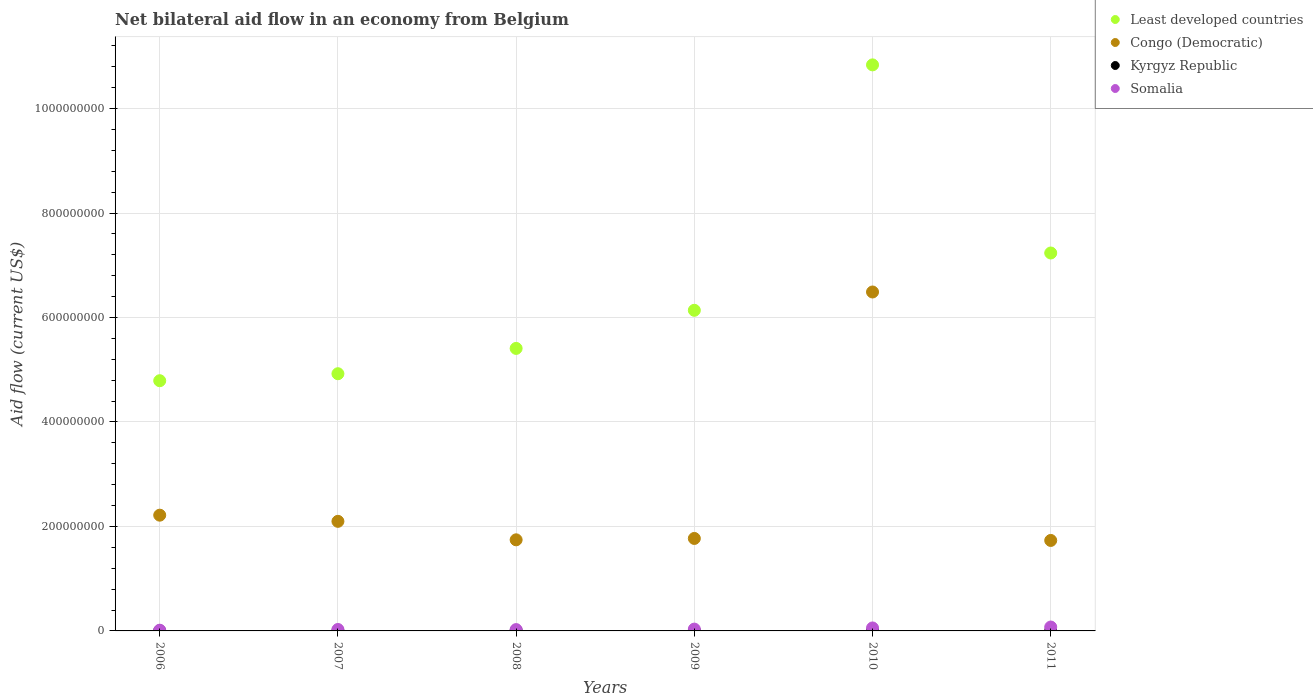How many different coloured dotlines are there?
Ensure brevity in your answer.  4. Is the number of dotlines equal to the number of legend labels?
Your answer should be compact. Yes. What is the net bilateral aid flow in Somalia in 2008?
Give a very brief answer. 2.56e+06. Across all years, what is the maximum net bilateral aid flow in Somalia?
Provide a succinct answer. 7.46e+06. Across all years, what is the minimum net bilateral aid flow in Kyrgyz Republic?
Ensure brevity in your answer.  1.40e+05. In which year was the net bilateral aid flow in Somalia maximum?
Offer a terse response. 2011. What is the total net bilateral aid flow in Somalia in the graph?
Keep it short and to the point. 2.34e+07. What is the difference between the net bilateral aid flow in Kyrgyz Republic in 2006 and the net bilateral aid flow in Least developed countries in 2011?
Your answer should be compact. -7.23e+08. What is the average net bilateral aid flow in Congo (Democratic) per year?
Give a very brief answer. 2.67e+08. In the year 2007, what is the difference between the net bilateral aid flow in Kyrgyz Republic and net bilateral aid flow in Somalia?
Provide a short and direct response. -2.62e+06. What is the ratio of the net bilateral aid flow in Least developed countries in 2007 to that in 2011?
Ensure brevity in your answer.  0.68. Is the net bilateral aid flow in Congo (Democratic) in 2009 less than that in 2011?
Keep it short and to the point. No. What is the difference between the highest and the second highest net bilateral aid flow in Congo (Democratic)?
Provide a succinct answer. 4.27e+08. What is the difference between the highest and the lowest net bilateral aid flow in Congo (Democratic)?
Make the answer very short. 4.76e+08. Is the sum of the net bilateral aid flow in Kyrgyz Republic in 2006 and 2009 greater than the maximum net bilateral aid flow in Somalia across all years?
Provide a succinct answer. No. Is it the case that in every year, the sum of the net bilateral aid flow in Kyrgyz Republic and net bilateral aid flow in Least developed countries  is greater than the net bilateral aid flow in Somalia?
Offer a very short reply. Yes. Is the net bilateral aid flow in Kyrgyz Republic strictly greater than the net bilateral aid flow in Congo (Democratic) over the years?
Your answer should be very brief. No. Is the net bilateral aid flow in Congo (Democratic) strictly less than the net bilateral aid flow in Kyrgyz Republic over the years?
Make the answer very short. No. How many dotlines are there?
Give a very brief answer. 4. How many years are there in the graph?
Keep it short and to the point. 6. Does the graph contain any zero values?
Provide a short and direct response. No. Does the graph contain grids?
Provide a succinct answer. Yes. Where does the legend appear in the graph?
Keep it short and to the point. Top right. What is the title of the graph?
Offer a terse response. Net bilateral aid flow in an economy from Belgium. What is the Aid flow (current US$) of Least developed countries in 2006?
Provide a short and direct response. 4.79e+08. What is the Aid flow (current US$) in Congo (Democratic) in 2006?
Give a very brief answer. 2.22e+08. What is the Aid flow (current US$) in Somalia in 2006?
Provide a succinct answer. 1.38e+06. What is the Aid flow (current US$) of Least developed countries in 2007?
Offer a terse response. 4.92e+08. What is the Aid flow (current US$) of Congo (Democratic) in 2007?
Provide a succinct answer. 2.10e+08. What is the Aid flow (current US$) of Kyrgyz Republic in 2007?
Give a very brief answer. 1.60e+05. What is the Aid flow (current US$) in Somalia in 2007?
Give a very brief answer. 2.78e+06. What is the Aid flow (current US$) of Least developed countries in 2008?
Your answer should be compact. 5.41e+08. What is the Aid flow (current US$) of Congo (Democratic) in 2008?
Make the answer very short. 1.74e+08. What is the Aid flow (current US$) in Kyrgyz Republic in 2008?
Offer a terse response. 6.30e+05. What is the Aid flow (current US$) in Somalia in 2008?
Provide a short and direct response. 2.56e+06. What is the Aid flow (current US$) in Least developed countries in 2009?
Offer a terse response. 6.14e+08. What is the Aid flow (current US$) in Congo (Democratic) in 2009?
Your answer should be very brief. 1.77e+08. What is the Aid flow (current US$) in Kyrgyz Republic in 2009?
Ensure brevity in your answer.  3.80e+05. What is the Aid flow (current US$) of Somalia in 2009?
Make the answer very short. 3.48e+06. What is the Aid flow (current US$) of Least developed countries in 2010?
Offer a very short reply. 1.08e+09. What is the Aid flow (current US$) in Congo (Democratic) in 2010?
Ensure brevity in your answer.  6.49e+08. What is the Aid flow (current US$) in Kyrgyz Republic in 2010?
Ensure brevity in your answer.  7.90e+05. What is the Aid flow (current US$) in Somalia in 2010?
Give a very brief answer. 5.69e+06. What is the Aid flow (current US$) of Least developed countries in 2011?
Offer a terse response. 7.23e+08. What is the Aid flow (current US$) in Congo (Democratic) in 2011?
Ensure brevity in your answer.  1.73e+08. What is the Aid flow (current US$) of Kyrgyz Republic in 2011?
Your answer should be compact. 1.40e+05. What is the Aid flow (current US$) in Somalia in 2011?
Keep it short and to the point. 7.46e+06. Across all years, what is the maximum Aid flow (current US$) in Least developed countries?
Provide a succinct answer. 1.08e+09. Across all years, what is the maximum Aid flow (current US$) in Congo (Democratic)?
Your response must be concise. 6.49e+08. Across all years, what is the maximum Aid flow (current US$) in Kyrgyz Republic?
Provide a short and direct response. 7.90e+05. Across all years, what is the maximum Aid flow (current US$) in Somalia?
Offer a very short reply. 7.46e+06. Across all years, what is the minimum Aid flow (current US$) of Least developed countries?
Your response must be concise. 4.79e+08. Across all years, what is the minimum Aid flow (current US$) in Congo (Democratic)?
Your response must be concise. 1.73e+08. Across all years, what is the minimum Aid flow (current US$) in Kyrgyz Republic?
Provide a short and direct response. 1.40e+05. Across all years, what is the minimum Aid flow (current US$) of Somalia?
Your answer should be very brief. 1.38e+06. What is the total Aid flow (current US$) of Least developed countries in the graph?
Provide a short and direct response. 3.93e+09. What is the total Aid flow (current US$) of Congo (Democratic) in the graph?
Provide a succinct answer. 1.60e+09. What is the total Aid flow (current US$) in Kyrgyz Republic in the graph?
Give a very brief answer. 2.29e+06. What is the total Aid flow (current US$) of Somalia in the graph?
Your answer should be very brief. 2.34e+07. What is the difference between the Aid flow (current US$) in Least developed countries in 2006 and that in 2007?
Ensure brevity in your answer.  -1.34e+07. What is the difference between the Aid flow (current US$) in Congo (Democratic) in 2006 and that in 2007?
Offer a very short reply. 1.18e+07. What is the difference between the Aid flow (current US$) of Somalia in 2006 and that in 2007?
Offer a terse response. -1.40e+06. What is the difference between the Aid flow (current US$) of Least developed countries in 2006 and that in 2008?
Offer a very short reply. -6.18e+07. What is the difference between the Aid flow (current US$) of Congo (Democratic) in 2006 and that in 2008?
Your answer should be compact. 4.72e+07. What is the difference between the Aid flow (current US$) of Kyrgyz Republic in 2006 and that in 2008?
Offer a terse response. -4.40e+05. What is the difference between the Aid flow (current US$) in Somalia in 2006 and that in 2008?
Keep it short and to the point. -1.18e+06. What is the difference between the Aid flow (current US$) of Least developed countries in 2006 and that in 2009?
Provide a short and direct response. -1.35e+08. What is the difference between the Aid flow (current US$) of Congo (Democratic) in 2006 and that in 2009?
Provide a succinct answer. 4.46e+07. What is the difference between the Aid flow (current US$) of Kyrgyz Republic in 2006 and that in 2009?
Your answer should be very brief. -1.90e+05. What is the difference between the Aid flow (current US$) of Somalia in 2006 and that in 2009?
Make the answer very short. -2.10e+06. What is the difference between the Aid flow (current US$) of Least developed countries in 2006 and that in 2010?
Keep it short and to the point. -6.05e+08. What is the difference between the Aid flow (current US$) of Congo (Democratic) in 2006 and that in 2010?
Provide a short and direct response. -4.27e+08. What is the difference between the Aid flow (current US$) of Kyrgyz Republic in 2006 and that in 2010?
Provide a short and direct response. -6.00e+05. What is the difference between the Aid flow (current US$) of Somalia in 2006 and that in 2010?
Keep it short and to the point. -4.31e+06. What is the difference between the Aid flow (current US$) in Least developed countries in 2006 and that in 2011?
Ensure brevity in your answer.  -2.44e+08. What is the difference between the Aid flow (current US$) in Congo (Democratic) in 2006 and that in 2011?
Your answer should be very brief. 4.84e+07. What is the difference between the Aid flow (current US$) in Kyrgyz Republic in 2006 and that in 2011?
Provide a succinct answer. 5.00e+04. What is the difference between the Aid flow (current US$) in Somalia in 2006 and that in 2011?
Offer a terse response. -6.08e+06. What is the difference between the Aid flow (current US$) of Least developed countries in 2007 and that in 2008?
Ensure brevity in your answer.  -4.85e+07. What is the difference between the Aid flow (current US$) in Congo (Democratic) in 2007 and that in 2008?
Ensure brevity in your answer.  3.54e+07. What is the difference between the Aid flow (current US$) of Kyrgyz Republic in 2007 and that in 2008?
Make the answer very short. -4.70e+05. What is the difference between the Aid flow (current US$) in Somalia in 2007 and that in 2008?
Make the answer very short. 2.20e+05. What is the difference between the Aid flow (current US$) of Least developed countries in 2007 and that in 2009?
Provide a succinct answer. -1.21e+08. What is the difference between the Aid flow (current US$) in Congo (Democratic) in 2007 and that in 2009?
Offer a terse response. 3.28e+07. What is the difference between the Aid flow (current US$) of Somalia in 2007 and that in 2009?
Keep it short and to the point. -7.00e+05. What is the difference between the Aid flow (current US$) of Least developed countries in 2007 and that in 2010?
Your answer should be compact. -5.91e+08. What is the difference between the Aid flow (current US$) of Congo (Democratic) in 2007 and that in 2010?
Ensure brevity in your answer.  -4.39e+08. What is the difference between the Aid flow (current US$) of Kyrgyz Republic in 2007 and that in 2010?
Make the answer very short. -6.30e+05. What is the difference between the Aid flow (current US$) of Somalia in 2007 and that in 2010?
Give a very brief answer. -2.91e+06. What is the difference between the Aid flow (current US$) in Least developed countries in 2007 and that in 2011?
Ensure brevity in your answer.  -2.31e+08. What is the difference between the Aid flow (current US$) of Congo (Democratic) in 2007 and that in 2011?
Your answer should be compact. 3.66e+07. What is the difference between the Aid flow (current US$) in Kyrgyz Republic in 2007 and that in 2011?
Your response must be concise. 2.00e+04. What is the difference between the Aid flow (current US$) of Somalia in 2007 and that in 2011?
Give a very brief answer. -4.68e+06. What is the difference between the Aid flow (current US$) in Least developed countries in 2008 and that in 2009?
Your response must be concise. -7.29e+07. What is the difference between the Aid flow (current US$) in Congo (Democratic) in 2008 and that in 2009?
Make the answer very short. -2.64e+06. What is the difference between the Aid flow (current US$) in Kyrgyz Republic in 2008 and that in 2009?
Offer a terse response. 2.50e+05. What is the difference between the Aid flow (current US$) of Somalia in 2008 and that in 2009?
Your response must be concise. -9.20e+05. What is the difference between the Aid flow (current US$) in Least developed countries in 2008 and that in 2010?
Keep it short and to the point. -5.43e+08. What is the difference between the Aid flow (current US$) in Congo (Democratic) in 2008 and that in 2010?
Provide a short and direct response. -4.74e+08. What is the difference between the Aid flow (current US$) in Somalia in 2008 and that in 2010?
Keep it short and to the point. -3.13e+06. What is the difference between the Aid flow (current US$) in Least developed countries in 2008 and that in 2011?
Provide a succinct answer. -1.83e+08. What is the difference between the Aid flow (current US$) of Congo (Democratic) in 2008 and that in 2011?
Offer a terse response. 1.19e+06. What is the difference between the Aid flow (current US$) in Somalia in 2008 and that in 2011?
Provide a short and direct response. -4.90e+06. What is the difference between the Aid flow (current US$) of Least developed countries in 2009 and that in 2010?
Keep it short and to the point. -4.70e+08. What is the difference between the Aid flow (current US$) of Congo (Democratic) in 2009 and that in 2010?
Keep it short and to the point. -4.72e+08. What is the difference between the Aid flow (current US$) in Kyrgyz Republic in 2009 and that in 2010?
Make the answer very short. -4.10e+05. What is the difference between the Aid flow (current US$) in Somalia in 2009 and that in 2010?
Offer a very short reply. -2.21e+06. What is the difference between the Aid flow (current US$) in Least developed countries in 2009 and that in 2011?
Give a very brief answer. -1.10e+08. What is the difference between the Aid flow (current US$) of Congo (Democratic) in 2009 and that in 2011?
Make the answer very short. 3.83e+06. What is the difference between the Aid flow (current US$) in Somalia in 2009 and that in 2011?
Keep it short and to the point. -3.98e+06. What is the difference between the Aid flow (current US$) of Least developed countries in 2010 and that in 2011?
Offer a terse response. 3.60e+08. What is the difference between the Aid flow (current US$) of Congo (Democratic) in 2010 and that in 2011?
Provide a short and direct response. 4.76e+08. What is the difference between the Aid flow (current US$) of Kyrgyz Republic in 2010 and that in 2011?
Offer a terse response. 6.50e+05. What is the difference between the Aid flow (current US$) of Somalia in 2010 and that in 2011?
Your response must be concise. -1.77e+06. What is the difference between the Aid flow (current US$) of Least developed countries in 2006 and the Aid flow (current US$) of Congo (Democratic) in 2007?
Give a very brief answer. 2.69e+08. What is the difference between the Aid flow (current US$) of Least developed countries in 2006 and the Aid flow (current US$) of Kyrgyz Republic in 2007?
Offer a terse response. 4.79e+08. What is the difference between the Aid flow (current US$) of Least developed countries in 2006 and the Aid flow (current US$) of Somalia in 2007?
Your answer should be compact. 4.76e+08. What is the difference between the Aid flow (current US$) in Congo (Democratic) in 2006 and the Aid flow (current US$) in Kyrgyz Republic in 2007?
Keep it short and to the point. 2.21e+08. What is the difference between the Aid flow (current US$) in Congo (Democratic) in 2006 and the Aid flow (current US$) in Somalia in 2007?
Offer a very short reply. 2.19e+08. What is the difference between the Aid flow (current US$) of Kyrgyz Republic in 2006 and the Aid flow (current US$) of Somalia in 2007?
Keep it short and to the point. -2.59e+06. What is the difference between the Aid flow (current US$) in Least developed countries in 2006 and the Aid flow (current US$) in Congo (Democratic) in 2008?
Provide a succinct answer. 3.05e+08. What is the difference between the Aid flow (current US$) in Least developed countries in 2006 and the Aid flow (current US$) in Kyrgyz Republic in 2008?
Your response must be concise. 4.78e+08. What is the difference between the Aid flow (current US$) in Least developed countries in 2006 and the Aid flow (current US$) in Somalia in 2008?
Give a very brief answer. 4.76e+08. What is the difference between the Aid flow (current US$) of Congo (Democratic) in 2006 and the Aid flow (current US$) of Kyrgyz Republic in 2008?
Ensure brevity in your answer.  2.21e+08. What is the difference between the Aid flow (current US$) of Congo (Democratic) in 2006 and the Aid flow (current US$) of Somalia in 2008?
Your answer should be very brief. 2.19e+08. What is the difference between the Aid flow (current US$) of Kyrgyz Republic in 2006 and the Aid flow (current US$) of Somalia in 2008?
Your answer should be very brief. -2.37e+06. What is the difference between the Aid flow (current US$) in Least developed countries in 2006 and the Aid flow (current US$) in Congo (Democratic) in 2009?
Ensure brevity in your answer.  3.02e+08. What is the difference between the Aid flow (current US$) in Least developed countries in 2006 and the Aid flow (current US$) in Kyrgyz Republic in 2009?
Offer a very short reply. 4.79e+08. What is the difference between the Aid flow (current US$) of Least developed countries in 2006 and the Aid flow (current US$) of Somalia in 2009?
Give a very brief answer. 4.75e+08. What is the difference between the Aid flow (current US$) in Congo (Democratic) in 2006 and the Aid flow (current US$) in Kyrgyz Republic in 2009?
Provide a succinct answer. 2.21e+08. What is the difference between the Aid flow (current US$) in Congo (Democratic) in 2006 and the Aid flow (current US$) in Somalia in 2009?
Your answer should be very brief. 2.18e+08. What is the difference between the Aid flow (current US$) in Kyrgyz Republic in 2006 and the Aid flow (current US$) in Somalia in 2009?
Give a very brief answer. -3.29e+06. What is the difference between the Aid flow (current US$) in Least developed countries in 2006 and the Aid flow (current US$) in Congo (Democratic) in 2010?
Your response must be concise. -1.70e+08. What is the difference between the Aid flow (current US$) of Least developed countries in 2006 and the Aid flow (current US$) of Kyrgyz Republic in 2010?
Offer a very short reply. 4.78e+08. What is the difference between the Aid flow (current US$) of Least developed countries in 2006 and the Aid flow (current US$) of Somalia in 2010?
Your response must be concise. 4.73e+08. What is the difference between the Aid flow (current US$) of Congo (Democratic) in 2006 and the Aid flow (current US$) of Kyrgyz Republic in 2010?
Make the answer very short. 2.21e+08. What is the difference between the Aid flow (current US$) in Congo (Democratic) in 2006 and the Aid flow (current US$) in Somalia in 2010?
Your answer should be compact. 2.16e+08. What is the difference between the Aid flow (current US$) of Kyrgyz Republic in 2006 and the Aid flow (current US$) of Somalia in 2010?
Your answer should be compact. -5.50e+06. What is the difference between the Aid flow (current US$) of Least developed countries in 2006 and the Aid flow (current US$) of Congo (Democratic) in 2011?
Your answer should be very brief. 3.06e+08. What is the difference between the Aid flow (current US$) in Least developed countries in 2006 and the Aid flow (current US$) in Kyrgyz Republic in 2011?
Ensure brevity in your answer.  4.79e+08. What is the difference between the Aid flow (current US$) of Least developed countries in 2006 and the Aid flow (current US$) of Somalia in 2011?
Your answer should be very brief. 4.72e+08. What is the difference between the Aid flow (current US$) of Congo (Democratic) in 2006 and the Aid flow (current US$) of Kyrgyz Republic in 2011?
Ensure brevity in your answer.  2.21e+08. What is the difference between the Aid flow (current US$) in Congo (Democratic) in 2006 and the Aid flow (current US$) in Somalia in 2011?
Offer a terse response. 2.14e+08. What is the difference between the Aid flow (current US$) in Kyrgyz Republic in 2006 and the Aid flow (current US$) in Somalia in 2011?
Your answer should be compact. -7.27e+06. What is the difference between the Aid flow (current US$) in Least developed countries in 2007 and the Aid flow (current US$) in Congo (Democratic) in 2008?
Your response must be concise. 3.18e+08. What is the difference between the Aid flow (current US$) of Least developed countries in 2007 and the Aid flow (current US$) of Kyrgyz Republic in 2008?
Provide a short and direct response. 4.92e+08. What is the difference between the Aid flow (current US$) of Least developed countries in 2007 and the Aid flow (current US$) of Somalia in 2008?
Make the answer very short. 4.90e+08. What is the difference between the Aid flow (current US$) in Congo (Democratic) in 2007 and the Aid flow (current US$) in Kyrgyz Republic in 2008?
Keep it short and to the point. 2.09e+08. What is the difference between the Aid flow (current US$) in Congo (Democratic) in 2007 and the Aid flow (current US$) in Somalia in 2008?
Keep it short and to the point. 2.07e+08. What is the difference between the Aid flow (current US$) in Kyrgyz Republic in 2007 and the Aid flow (current US$) in Somalia in 2008?
Offer a very short reply. -2.40e+06. What is the difference between the Aid flow (current US$) of Least developed countries in 2007 and the Aid flow (current US$) of Congo (Democratic) in 2009?
Your answer should be compact. 3.15e+08. What is the difference between the Aid flow (current US$) of Least developed countries in 2007 and the Aid flow (current US$) of Kyrgyz Republic in 2009?
Give a very brief answer. 4.92e+08. What is the difference between the Aid flow (current US$) in Least developed countries in 2007 and the Aid flow (current US$) in Somalia in 2009?
Make the answer very short. 4.89e+08. What is the difference between the Aid flow (current US$) of Congo (Democratic) in 2007 and the Aid flow (current US$) of Kyrgyz Republic in 2009?
Provide a short and direct response. 2.09e+08. What is the difference between the Aid flow (current US$) in Congo (Democratic) in 2007 and the Aid flow (current US$) in Somalia in 2009?
Your answer should be very brief. 2.06e+08. What is the difference between the Aid flow (current US$) in Kyrgyz Republic in 2007 and the Aid flow (current US$) in Somalia in 2009?
Your answer should be very brief. -3.32e+06. What is the difference between the Aid flow (current US$) in Least developed countries in 2007 and the Aid flow (current US$) in Congo (Democratic) in 2010?
Provide a short and direct response. -1.56e+08. What is the difference between the Aid flow (current US$) of Least developed countries in 2007 and the Aid flow (current US$) of Kyrgyz Republic in 2010?
Your answer should be very brief. 4.92e+08. What is the difference between the Aid flow (current US$) of Least developed countries in 2007 and the Aid flow (current US$) of Somalia in 2010?
Ensure brevity in your answer.  4.87e+08. What is the difference between the Aid flow (current US$) of Congo (Democratic) in 2007 and the Aid flow (current US$) of Kyrgyz Republic in 2010?
Provide a succinct answer. 2.09e+08. What is the difference between the Aid flow (current US$) of Congo (Democratic) in 2007 and the Aid flow (current US$) of Somalia in 2010?
Your response must be concise. 2.04e+08. What is the difference between the Aid flow (current US$) of Kyrgyz Republic in 2007 and the Aid flow (current US$) of Somalia in 2010?
Offer a terse response. -5.53e+06. What is the difference between the Aid flow (current US$) of Least developed countries in 2007 and the Aid flow (current US$) of Congo (Democratic) in 2011?
Your answer should be very brief. 3.19e+08. What is the difference between the Aid flow (current US$) in Least developed countries in 2007 and the Aid flow (current US$) in Kyrgyz Republic in 2011?
Provide a succinct answer. 4.92e+08. What is the difference between the Aid flow (current US$) in Least developed countries in 2007 and the Aid flow (current US$) in Somalia in 2011?
Offer a very short reply. 4.85e+08. What is the difference between the Aid flow (current US$) in Congo (Democratic) in 2007 and the Aid flow (current US$) in Kyrgyz Republic in 2011?
Your response must be concise. 2.10e+08. What is the difference between the Aid flow (current US$) of Congo (Democratic) in 2007 and the Aid flow (current US$) of Somalia in 2011?
Provide a short and direct response. 2.02e+08. What is the difference between the Aid flow (current US$) in Kyrgyz Republic in 2007 and the Aid flow (current US$) in Somalia in 2011?
Offer a very short reply. -7.30e+06. What is the difference between the Aid flow (current US$) of Least developed countries in 2008 and the Aid flow (current US$) of Congo (Democratic) in 2009?
Keep it short and to the point. 3.64e+08. What is the difference between the Aid flow (current US$) of Least developed countries in 2008 and the Aid flow (current US$) of Kyrgyz Republic in 2009?
Offer a very short reply. 5.40e+08. What is the difference between the Aid flow (current US$) of Least developed countries in 2008 and the Aid flow (current US$) of Somalia in 2009?
Your answer should be compact. 5.37e+08. What is the difference between the Aid flow (current US$) of Congo (Democratic) in 2008 and the Aid flow (current US$) of Kyrgyz Republic in 2009?
Your answer should be very brief. 1.74e+08. What is the difference between the Aid flow (current US$) in Congo (Democratic) in 2008 and the Aid flow (current US$) in Somalia in 2009?
Make the answer very short. 1.71e+08. What is the difference between the Aid flow (current US$) of Kyrgyz Republic in 2008 and the Aid flow (current US$) of Somalia in 2009?
Provide a short and direct response. -2.85e+06. What is the difference between the Aid flow (current US$) in Least developed countries in 2008 and the Aid flow (current US$) in Congo (Democratic) in 2010?
Your answer should be very brief. -1.08e+08. What is the difference between the Aid flow (current US$) in Least developed countries in 2008 and the Aid flow (current US$) in Kyrgyz Republic in 2010?
Keep it short and to the point. 5.40e+08. What is the difference between the Aid flow (current US$) in Least developed countries in 2008 and the Aid flow (current US$) in Somalia in 2010?
Offer a terse response. 5.35e+08. What is the difference between the Aid flow (current US$) of Congo (Democratic) in 2008 and the Aid flow (current US$) of Kyrgyz Republic in 2010?
Offer a very short reply. 1.74e+08. What is the difference between the Aid flow (current US$) of Congo (Democratic) in 2008 and the Aid flow (current US$) of Somalia in 2010?
Make the answer very short. 1.69e+08. What is the difference between the Aid flow (current US$) of Kyrgyz Republic in 2008 and the Aid flow (current US$) of Somalia in 2010?
Offer a very short reply. -5.06e+06. What is the difference between the Aid flow (current US$) of Least developed countries in 2008 and the Aid flow (current US$) of Congo (Democratic) in 2011?
Your response must be concise. 3.68e+08. What is the difference between the Aid flow (current US$) in Least developed countries in 2008 and the Aid flow (current US$) in Kyrgyz Republic in 2011?
Your answer should be compact. 5.41e+08. What is the difference between the Aid flow (current US$) in Least developed countries in 2008 and the Aid flow (current US$) in Somalia in 2011?
Your answer should be compact. 5.33e+08. What is the difference between the Aid flow (current US$) in Congo (Democratic) in 2008 and the Aid flow (current US$) in Kyrgyz Republic in 2011?
Your response must be concise. 1.74e+08. What is the difference between the Aid flow (current US$) in Congo (Democratic) in 2008 and the Aid flow (current US$) in Somalia in 2011?
Provide a short and direct response. 1.67e+08. What is the difference between the Aid flow (current US$) of Kyrgyz Republic in 2008 and the Aid flow (current US$) of Somalia in 2011?
Make the answer very short. -6.83e+06. What is the difference between the Aid flow (current US$) in Least developed countries in 2009 and the Aid flow (current US$) in Congo (Democratic) in 2010?
Give a very brief answer. -3.51e+07. What is the difference between the Aid flow (current US$) of Least developed countries in 2009 and the Aid flow (current US$) of Kyrgyz Republic in 2010?
Provide a succinct answer. 6.13e+08. What is the difference between the Aid flow (current US$) in Least developed countries in 2009 and the Aid flow (current US$) in Somalia in 2010?
Give a very brief answer. 6.08e+08. What is the difference between the Aid flow (current US$) in Congo (Democratic) in 2009 and the Aid flow (current US$) in Kyrgyz Republic in 2010?
Ensure brevity in your answer.  1.76e+08. What is the difference between the Aid flow (current US$) of Congo (Democratic) in 2009 and the Aid flow (current US$) of Somalia in 2010?
Provide a succinct answer. 1.71e+08. What is the difference between the Aid flow (current US$) in Kyrgyz Republic in 2009 and the Aid flow (current US$) in Somalia in 2010?
Give a very brief answer. -5.31e+06. What is the difference between the Aid flow (current US$) of Least developed countries in 2009 and the Aid flow (current US$) of Congo (Democratic) in 2011?
Your answer should be very brief. 4.41e+08. What is the difference between the Aid flow (current US$) of Least developed countries in 2009 and the Aid flow (current US$) of Kyrgyz Republic in 2011?
Your answer should be very brief. 6.14e+08. What is the difference between the Aid flow (current US$) of Least developed countries in 2009 and the Aid flow (current US$) of Somalia in 2011?
Ensure brevity in your answer.  6.06e+08. What is the difference between the Aid flow (current US$) in Congo (Democratic) in 2009 and the Aid flow (current US$) in Kyrgyz Republic in 2011?
Keep it short and to the point. 1.77e+08. What is the difference between the Aid flow (current US$) of Congo (Democratic) in 2009 and the Aid flow (current US$) of Somalia in 2011?
Offer a terse response. 1.70e+08. What is the difference between the Aid flow (current US$) in Kyrgyz Republic in 2009 and the Aid flow (current US$) in Somalia in 2011?
Your response must be concise. -7.08e+06. What is the difference between the Aid flow (current US$) of Least developed countries in 2010 and the Aid flow (current US$) of Congo (Democratic) in 2011?
Offer a terse response. 9.10e+08. What is the difference between the Aid flow (current US$) of Least developed countries in 2010 and the Aid flow (current US$) of Kyrgyz Republic in 2011?
Provide a succinct answer. 1.08e+09. What is the difference between the Aid flow (current US$) in Least developed countries in 2010 and the Aid flow (current US$) in Somalia in 2011?
Provide a short and direct response. 1.08e+09. What is the difference between the Aid flow (current US$) in Congo (Democratic) in 2010 and the Aid flow (current US$) in Kyrgyz Republic in 2011?
Provide a short and direct response. 6.49e+08. What is the difference between the Aid flow (current US$) of Congo (Democratic) in 2010 and the Aid flow (current US$) of Somalia in 2011?
Offer a very short reply. 6.41e+08. What is the difference between the Aid flow (current US$) in Kyrgyz Republic in 2010 and the Aid flow (current US$) in Somalia in 2011?
Your answer should be compact. -6.67e+06. What is the average Aid flow (current US$) of Least developed countries per year?
Your answer should be very brief. 6.55e+08. What is the average Aid flow (current US$) in Congo (Democratic) per year?
Make the answer very short. 2.67e+08. What is the average Aid flow (current US$) of Kyrgyz Republic per year?
Your answer should be very brief. 3.82e+05. What is the average Aid flow (current US$) in Somalia per year?
Your answer should be very brief. 3.89e+06. In the year 2006, what is the difference between the Aid flow (current US$) of Least developed countries and Aid flow (current US$) of Congo (Democratic)?
Your answer should be very brief. 2.57e+08. In the year 2006, what is the difference between the Aid flow (current US$) of Least developed countries and Aid flow (current US$) of Kyrgyz Republic?
Keep it short and to the point. 4.79e+08. In the year 2006, what is the difference between the Aid flow (current US$) of Least developed countries and Aid flow (current US$) of Somalia?
Offer a terse response. 4.78e+08. In the year 2006, what is the difference between the Aid flow (current US$) of Congo (Democratic) and Aid flow (current US$) of Kyrgyz Republic?
Offer a very short reply. 2.21e+08. In the year 2006, what is the difference between the Aid flow (current US$) in Congo (Democratic) and Aid flow (current US$) in Somalia?
Ensure brevity in your answer.  2.20e+08. In the year 2006, what is the difference between the Aid flow (current US$) in Kyrgyz Republic and Aid flow (current US$) in Somalia?
Provide a succinct answer. -1.19e+06. In the year 2007, what is the difference between the Aid flow (current US$) of Least developed countries and Aid flow (current US$) of Congo (Democratic)?
Make the answer very short. 2.83e+08. In the year 2007, what is the difference between the Aid flow (current US$) of Least developed countries and Aid flow (current US$) of Kyrgyz Republic?
Offer a terse response. 4.92e+08. In the year 2007, what is the difference between the Aid flow (current US$) in Least developed countries and Aid flow (current US$) in Somalia?
Make the answer very short. 4.90e+08. In the year 2007, what is the difference between the Aid flow (current US$) in Congo (Democratic) and Aid flow (current US$) in Kyrgyz Republic?
Your response must be concise. 2.10e+08. In the year 2007, what is the difference between the Aid flow (current US$) in Congo (Democratic) and Aid flow (current US$) in Somalia?
Your answer should be very brief. 2.07e+08. In the year 2007, what is the difference between the Aid flow (current US$) in Kyrgyz Republic and Aid flow (current US$) in Somalia?
Your answer should be compact. -2.62e+06. In the year 2008, what is the difference between the Aid flow (current US$) in Least developed countries and Aid flow (current US$) in Congo (Democratic)?
Your answer should be compact. 3.66e+08. In the year 2008, what is the difference between the Aid flow (current US$) of Least developed countries and Aid flow (current US$) of Kyrgyz Republic?
Your response must be concise. 5.40e+08. In the year 2008, what is the difference between the Aid flow (current US$) of Least developed countries and Aid flow (current US$) of Somalia?
Offer a very short reply. 5.38e+08. In the year 2008, what is the difference between the Aid flow (current US$) of Congo (Democratic) and Aid flow (current US$) of Kyrgyz Republic?
Provide a short and direct response. 1.74e+08. In the year 2008, what is the difference between the Aid flow (current US$) in Congo (Democratic) and Aid flow (current US$) in Somalia?
Provide a succinct answer. 1.72e+08. In the year 2008, what is the difference between the Aid flow (current US$) of Kyrgyz Republic and Aid flow (current US$) of Somalia?
Offer a very short reply. -1.93e+06. In the year 2009, what is the difference between the Aid flow (current US$) of Least developed countries and Aid flow (current US$) of Congo (Democratic)?
Your response must be concise. 4.37e+08. In the year 2009, what is the difference between the Aid flow (current US$) in Least developed countries and Aid flow (current US$) in Kyrgyz Republic?
Provide a short and direct response. 6.13e+08. In the year 2009, what is the difference between the Aid flow (current US$) in Least developed countries and Aid flow (current US$) in Somalia?
Provide a short and direct response. 6.10e+08. In the year 2009, what is the difference between the Aid flow (current US$) in Congo (Democratic) and Aid flow (current US$) in Kyrgyz Republic?
Keep it short and to the point. 1.77e+08. In the year 2009, what is the difference between the Aid flow (current US$) of Congo (Democratic) and Aid flow (current US$) of Somalia?
Make the answer very short. 1.74e+08. In the year 2009, what is the difference between the Aid flow (current US$) of Kyrgyz Republic and Aid flow (current US$) of Somalia?
Provide a succinct answer. -3.10e+06. In the year 2010, what is the difference between the Aid flow (current US$) of Least developed countries and Aid flow (current US$) of Congo (Democratic)?
Ensure brevity in your answer.  4.35e+08. In the year 2010, what is the difference between the Aid flow (current US$) in Least developed countries and Aid flow (current US$) in Kyrgyz Republic?
Your response must be concise. 1.08e+09. In the year 2010, what is the difference between the Aid flow (current US$) in Least developed countries and Aid flow (current US$) in Somalia?
Your response must be concise. 1.08e+09. In the year 2010, what is the difference between the Aid flow (current US$) of Congo (Democratic) and Aid flow (current US$) of Kyrgyz Republic?
Your answer should be compact. 6.48e+08. In the year 2010, what is the difference between the Aid flow (current US$) of Congo (Democratic) and Aid flow (current US$) of Somalia?
Provide a short and direct response. 6.43e+08. In the year 2010, what is the difference between the Aid flow (current US$) in Kyrgyz Republic and Aid flow (current US$) in Somalia?
Offer a very short reply. -4.90e+06. In the year 2011, what is the difference between the Aid flow (current US$) of Least developed countries and Aid flow (current US$) of Congo (Democratic)?
Your response must be concise. 5.50e+08. In the year 2011, what is the difference between the Aid flow (current US$) of Least developed countries and Aid flow (current US$) of Kyrgyz Republic?
Make the answer very short. 7.23e+08. In the year 2011, what is the difference between the Aid flow (current US$) of Least developed countries and Aid flow (current US$) of Somalia?
Provide a succinct answer. 7.16e+08. In the year 2011, what is the difference between the Aid flow (current US$) of Congo (Democratic) and Aid flow (current US$) of Kyrgyz Republic?
Make the answer very short. 1.73e+08. In the year 2011, what is the difference between the Aid flow (current US$) in Congo (Democratic) and Aid flow (current US$) in Somalia?
Provide a succinct answer. 1.66e+08. In the year 2011, what is the difference between the Aid flow (current US$) in Kyrgyz Republic and Aid flow (current US$) in Somalia?
Your response must be concise. -7.32e+06. What is the ratio of the Aid flow (current US$) in Least developed countries in 2006 to that in 2007?
Make the answer very short. 0.97. What is the ratio of the Aid flow (current US$) of Congo (Democratic) in 2006 to that in 2007?
Keep it short and to the point. 1.06. What is the ratio of the Aid flow (current US$) of Kyrgyz Republic in 2006 to that in 2007?
Provide a short and direct response. 1.19. What is the ratio of the Aid flow (current US$) in Somalia in 2006 to that in 2007?
Offer a terse response. 0.5. What is the ratio of the Aid flow (current US$) in Least developed countries in 2006 to that in 2008?
Ensure brevity in your answer.  0.89. What is the ratio of the Aid flow (current US$) in Congo (Democratic) in 2006 to that in 2008?
Ensure brevity in your answer.  1.27. What is the ratio of the Aid flow (current US$) of Kyrgyz Republic in 2006 to that in 2008?
Offer a very short reply. 0.3. What is the ratio of the Aid flow (current US$) of Somalia in 2006 to that in 2008?
Provide a succinct answer. 0.54. What is the ratio of the Aid flow (current US$) of Least developed countries in 2006 to that in 2009?
Provide a succinct answer. 0.78. What is the ratio of the Aid flow (current US$) in Congo (Democratic) in 2006 to that in 2009?
Provide a succinct answer. 1.25. What is the ratio of the Aid flow (current US$) of Kyrgyz Republic in 2006 to that in 2009?
Your response must be concise. 0.5. What is the ratio of the Aid flow (current US$) of Somalia in 2006 to that in 2009?
Offer a very short reply. 0.4. What is the ratio of the Aid flow (current US$) in Least developed countries in 2006 to that in 2010?
Provide a short and direct response. 0.44. What is the ratio of the Aid flow (current US$) of Congo (Democratic) in 2006 to that in 2010?
Ensure brevity in your answer.  0.34. What is the ratio of the Aid flow (current US$) of Kyrgyz Republic in 2006 to that in 2010?
Give a very brief answer. 0.24. What is the ratio of the Aid flow (current US$) in Somalia in 2006 to that in 2010?
Keep it short and to the point. 0.24. What is the ratio of the Aid flow (current US$) in Least developed countries in 2006 to that in 2011?
Make the answer very short. 0.66. What is the ratio of the Aid flow (current US$) in Congo (Democratic) in 2006 to that in 2011?
Provide a short and direct response. 1.28. What is the ratio of the Aid flow (current US$) of Kyrgyz Republic in 2006 to that in 2011?
Provide a succinct answer. 1.36. What is the ratio of the Aid flow (current US$) in Somalia in 2006 to that in 2011?
Your answer should be very brief. 0.18. What is the ratio of the Aid flow (current US$) of Least developed countries in 2007 to that in 2008?
Ensure brevity in your answer.  0.91. What is the ratio of the Aid flow (current US$) of Congo (Democratic) in 2007 to that in 2008?
Offer a terse response. 1.2. What is the ratio of the Aid flow (current US$) in Kyrgyz Republic in 2007 to that in 2008?
Your answer should be compact. 0.25. What is the ratio of the Aid flow (current US$) of Somalia in 2007 to that in 2008?
Keep it short and to the point. 1.09. What is the ratio of the Aid flow (current US$) in Least developed countries in 2007 to that in 2009?
Provide a short and direct response. 0.8. What is the ratio of the Aid flow (current US$) in Congo (Democratic) in 2007 to that in 2009?
Your answer should be compact. 1.19. What is the ratio of the Aid flow (current US$) in Kyrgyz Republic in 2007 to that in 2009?
Provide a succinct answer. 0.42. What is the ratio of the Aid flow (current US$) in Somalia in 2007 to that in 2009?
Provide a short and direct response. 0.8. What is the ratio of the Aid flow (current US$) in Least developed countries in 2007 to that in 2010?
Ensure brevity in your answer.  0.45. What is the ratio of the Aid flow (current US$) of Congo (Democratic) in 2007 to that in 2010?
Ensure brevity in your answer.  0.32. What is the ratio of the Aid flow (current US$) in Kyrgyz Republic in 2007 to that in 2010?
Make the answer very short. 0.2. What is the ratio of the Aid flow (current US$) of Somalia in 2007 to that in 2010?
Offer a terse response. 0.49. What is the ratio of the Aid flow (current US$) of Least developed countries in 2007 to that in 2011?
Give a very brief answer. 0.68. What is the ratio of the Aid flow (current US$) in Congo (Democratic) in 2007 to that in 2011?
Offer a very short reply. 1.21. What is the ratio of the Aid flow (current US$) of Kyrgyz Republic in 2007 to that in 2011?
Give a very brief answer. 1.14. What is the ratio of the Aid flow (current US$) of Somalia in 2007 to that in 2011?
Provide a succinct answer. 0.37. What is the ratio of the Aid flow (current US$) of Least developed countries in 2008 to that in 2009?
Give a very brief answer. 0.88. What is the ratio of the Aid flow (current US$) in Congo (Democratic) in 2008 to that in 2009?
Keep it short and to the point. 0.99. What is the ratio of the Aid flow (current US$) in Kyrgyz Republic in 2008 to that in 2009?
Offer a very short reply. 1.66. What is the ratio of the Aid flow (current US$) in Somalia in 2008 to that in 2009?
Provide a short and direct response. 0.74. What is the ratio of the Aid flow (current US$) of Least developed countries in 2008 to that in 2010?
Offer a very short reply. 0.5. What is the ratio of the Aid flow (current US$) in Congo (Democratic) in 2008 to that in 2010?
Give a very brief answer. 0.27. What is the ratio of the Aid flow (current US$) of Kyrgyz Republic in 2008 to that in 2010?
Your answer should be compact. 0.8. What is the ratio of the Aid flow (current US$) of Somalia in 2008 to that in 2010?
Make the answer very short. 0.45. What is the ratio of the Aid flow (current US$) in Least developed countries in 2008 to that in 2011?
Provide a succinct answer. 0.75. What is the ratio of the Aid flow (current US$) in Congo (Democratic) in 2008 to that in 2011?
Offer a terse response. 1.01. What is the ratio of the Aid flow (current US$) in Somalia in 2008 to that in 2011?
Provide a short and direct response. 0.34. What is the ratio of the Aid flow (current US$) in Least developed countries in 2009 to that in 2010?
Offer a terse response. 0.57. What is the ratio of the Aid flow (current US$) of Congo (Democratic) in 2009 to that in 2010?
Ensure brevity in your answer.  0.27. What is the ratio of the Aid flow (current US$) of Kyrgyz Republic in 2009 to that in 2010?
Offer a very short reply. 0.48. What is the ratio of the Aid flow (current US$) of Somalia in 2009 to that in 2010?
Provide a short and direct response. 0.61. What is the ratio of the Aid flow (current US$) of Least developed countries in 2009 to that in 2011?
Your response must be concise. 0.85. What is the ratio of the Aid flow (current US$) in Congo (Democratic) in 2009 to that in 2011?
Ensure brevity in your answer.  1.02. What is the ratio of the Aid flow (current US$) in Kyrgyz Republic in 2009 to that in 2011?
Offer a very short reply. 2.71. What is the ratio of the Aid flow (current US$) in Somalia in 2009 to that in 2011?
Make the answer very short. 0.47. What is the ratio of the Aid flow (current US$) in Least developed countries in 2010 to that in 2011?
Offer a very short reply. 1.5. What is the ratio of the Aid flow (current US$) of Congo (Democratic) in 2010 to that in 2011?
Your response must be concise. 3.75. What is the ratio of the Aid flow (current US$) of Kyrgyz Republic in 2010 to that in 2011?
Your answer should be compact. 5.64. What is the ratio of the Aid flow (current US$) of Somalia in 2010 to that in 2011?
Provide a succinct answer. 0.76. What is the difference between the highest and the second highest Aid flow (current US$) of Least developed countries?
Your answer should be very brief. 3.60e+08. What is the difference between the highest and the second highest Aid flow (current US$) of Congo (Democratic)?
Your answer should be very brief. 4.27e+08. What is the difference between the highest and the second highest Aid flow (current US$) in Somalia?
Your response must be concise. 1.77e+06. What is the difference between the highest and the lowest Aid flow (current US$) in Least developed countries?
Your response must be concise. 6.05e+08. What is the difference between the highest and the lowest Aid flow (current US$) of Congo (Democratic)?
Offer a terse response. 4.76e+08. What is the difference between the highest and the lowest Aid flow (current US$) of Kyrgyz Republic?
Make the answer very short. 6.50e+05. What is the difference between the highest and the lowest Aid flow (current US$) of Somalia?
Ensure brevity in your answer.  6.08e+06. 